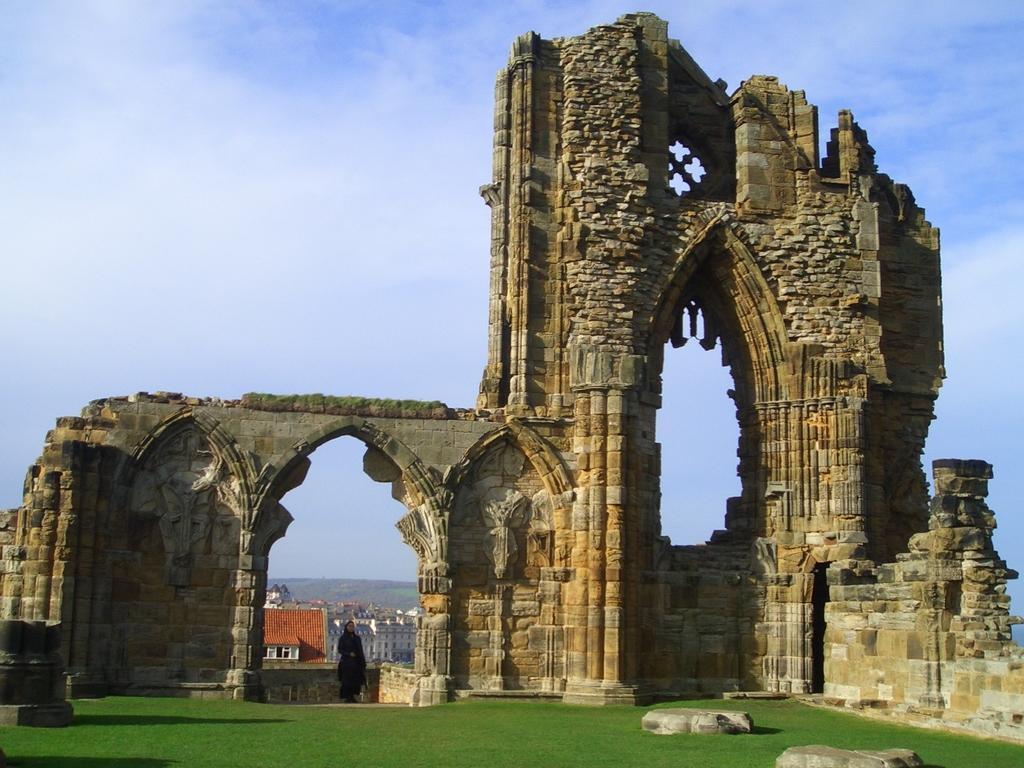Describe this image in one or two sentences. There is a person standing near an architecture. Which is near grass on the ground on which, there is grass and slabs. In the background, there are buildings, there is a mountain and there are clouds in the blue sky. 